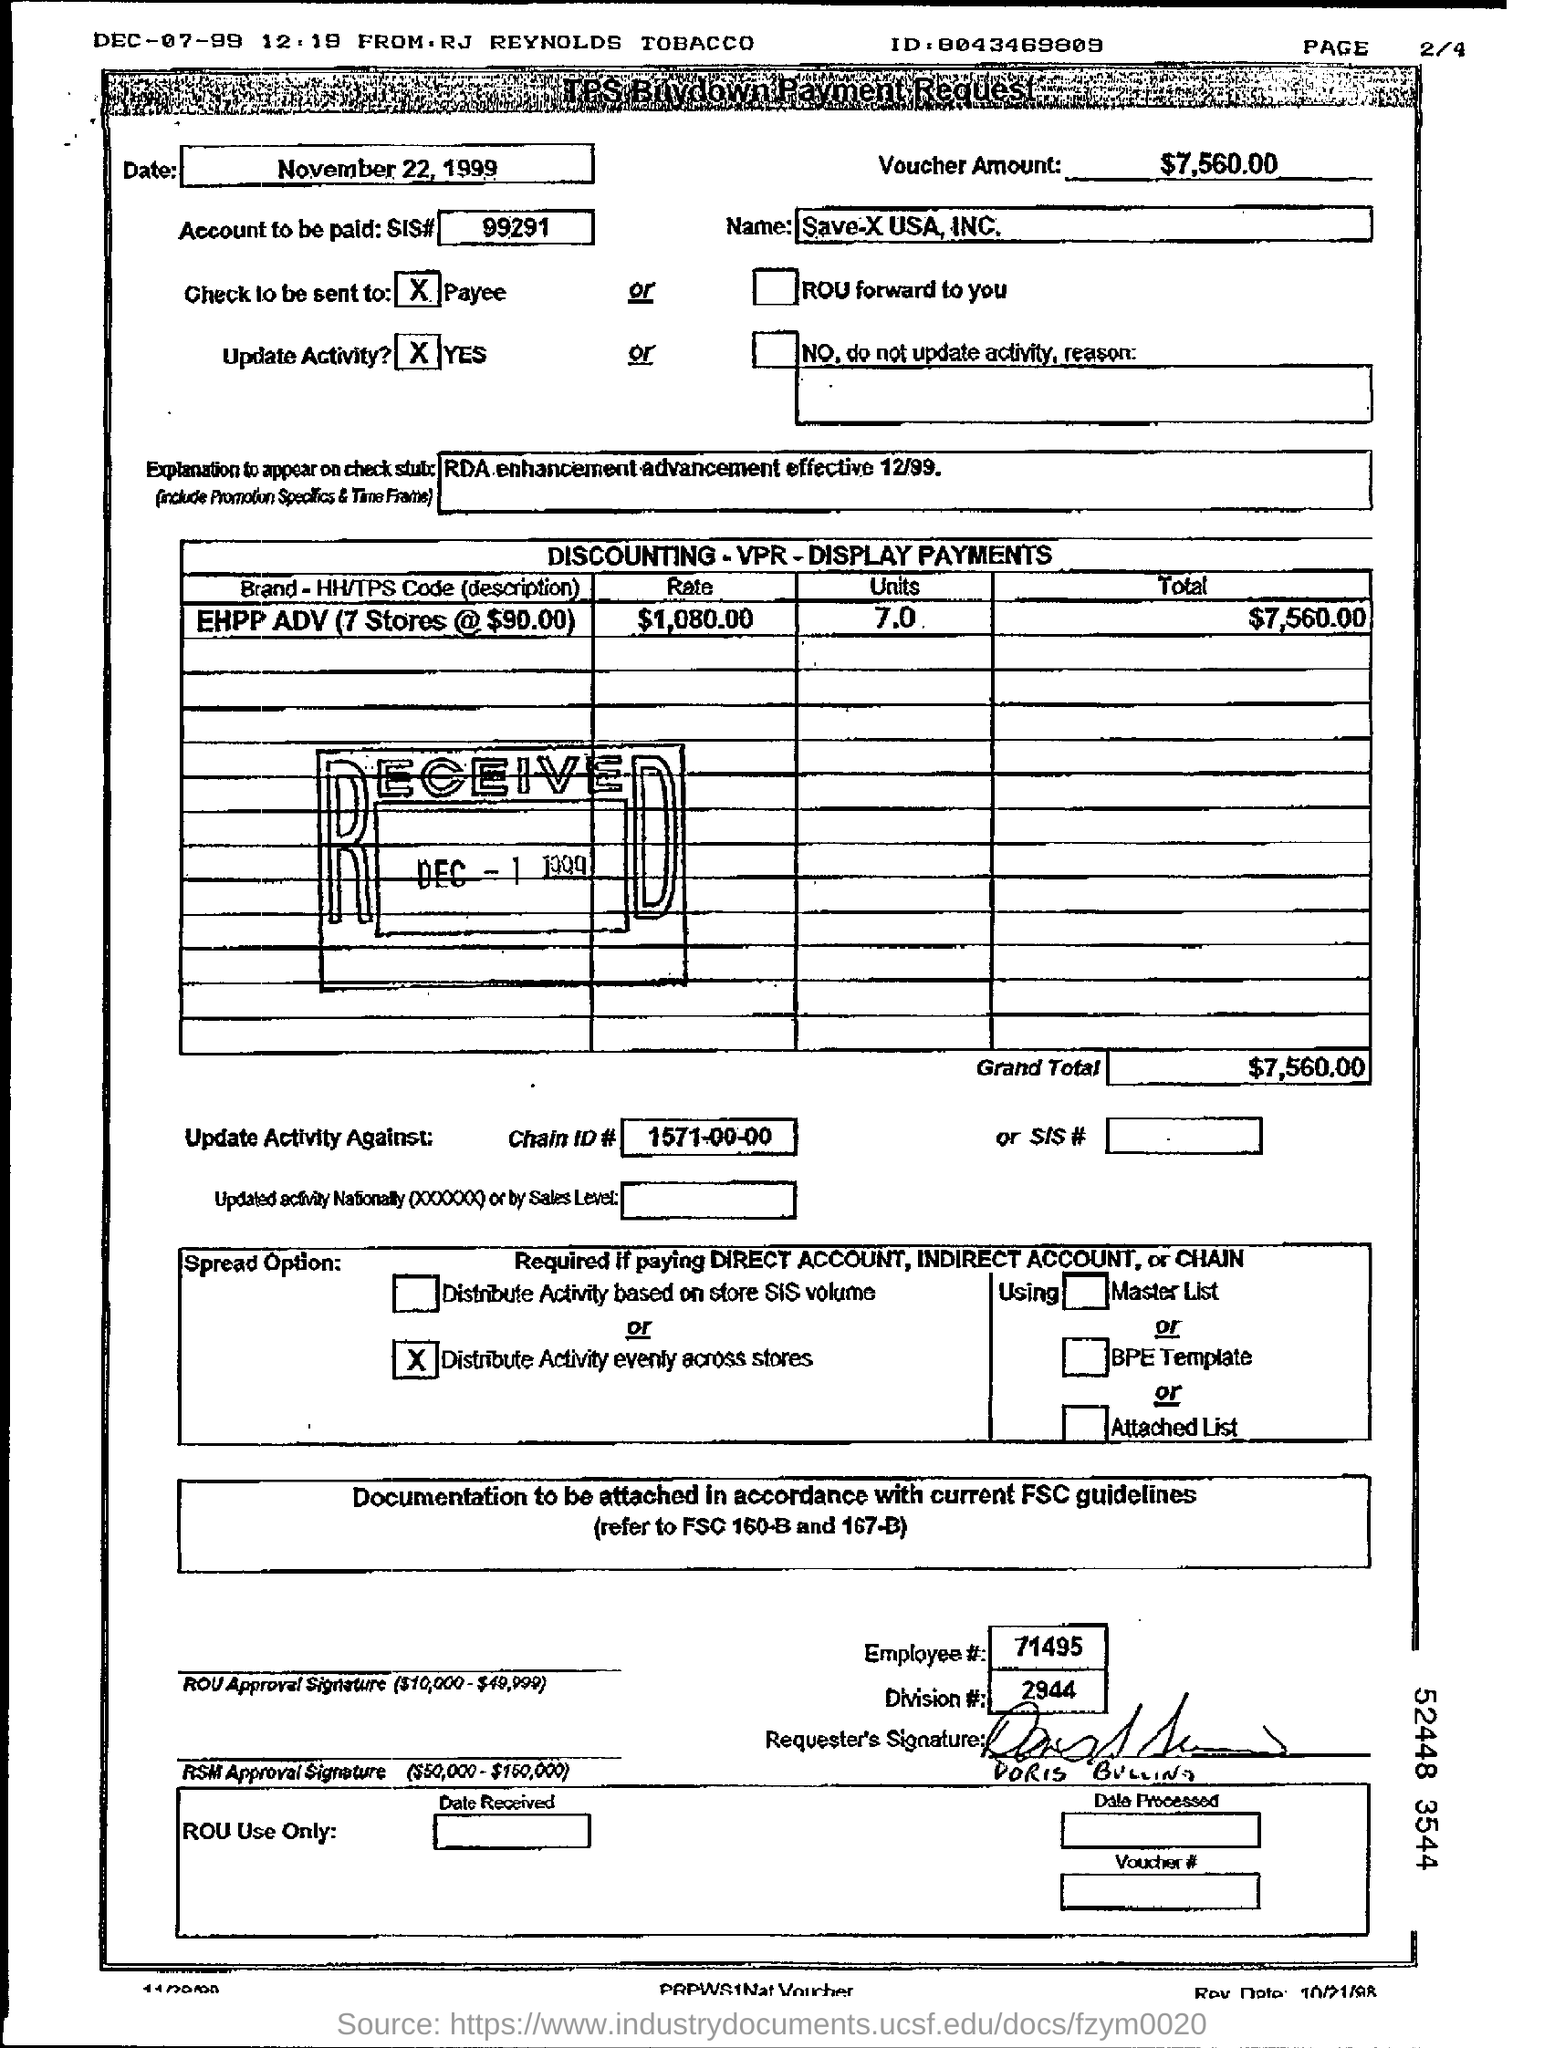How much amount in the voucher?
Make the answer very short. $7,560.00. What is the name in the tps buydown payment request?
Your answer should be compact. Save-X USA, INC. What is the explanation to appear on check status ?
Make the answer very short. RDA enhancement advancement effective 12/99. What is the brand - hh/tps code (description)?
Provide a short and direct response. EHPP ADV (7 stores @ $90.00). What is the rate for the ehpp adv (7 stores @ $90.00) ?
Give a very brief answer. 1,080.00. How many units for the ehpp adv (7 stores @ $90.00) ?
Offer a terse response. 7.0. What is the total amount for the ehpp adv (7 stores @ $90.00) ?
Keep it short and to the point. $7,560.00. What is the chainid# in the payment request?
Your response must be concise. 1571-00-00. What is the number for the employee#?
Your answer should be very brief. 71495. 